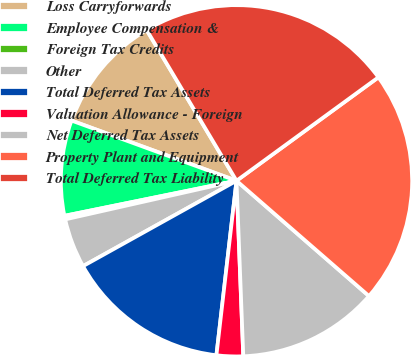Convert chart to OTSL. <chart><loc_0><loc_0><loc_500><loc_500><pie_chart><fcel>Loss Carryforwards<fcel>Employee Compensation &<fcel>Foreign Tax Credits<fcel>Other<fcel>Total Deferred Tax Assets<fcel>Valuation Allowance - Foreign<fcel>Net Deferred Tax Assets<fcel>Property Plant and Equipment<fcel>Total Deferred Tax Liability<nl><fcel>10.88%<fcel>8.77%<fcel>0.33%<fcel>4.55%<fcel>15.1%<fcel>2.44%<fcel>12.99%<fcel>21.43%<fcel>23.53%<nl></chart> 